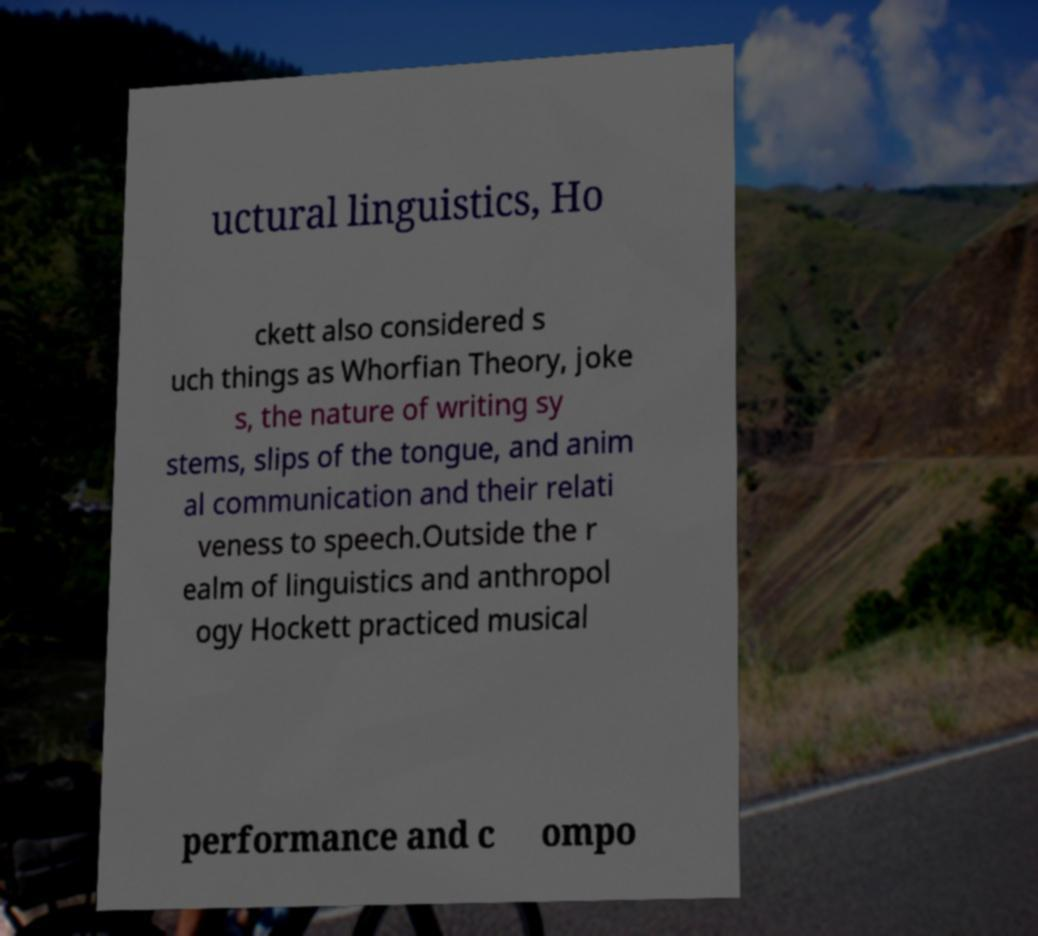For documentation purposes, I need the text within this image transcribed. Could you provide that? uctural linguistics, Ho ckett also considered s uch things as Whorfian Theory, joke s, the nature of writing sy stems, slips of the tongue, and anim al communication and their relati veness to speech.Outside the r ealm of linguistics and anthropol ogy Hockett practiced musical performance and c ompo 